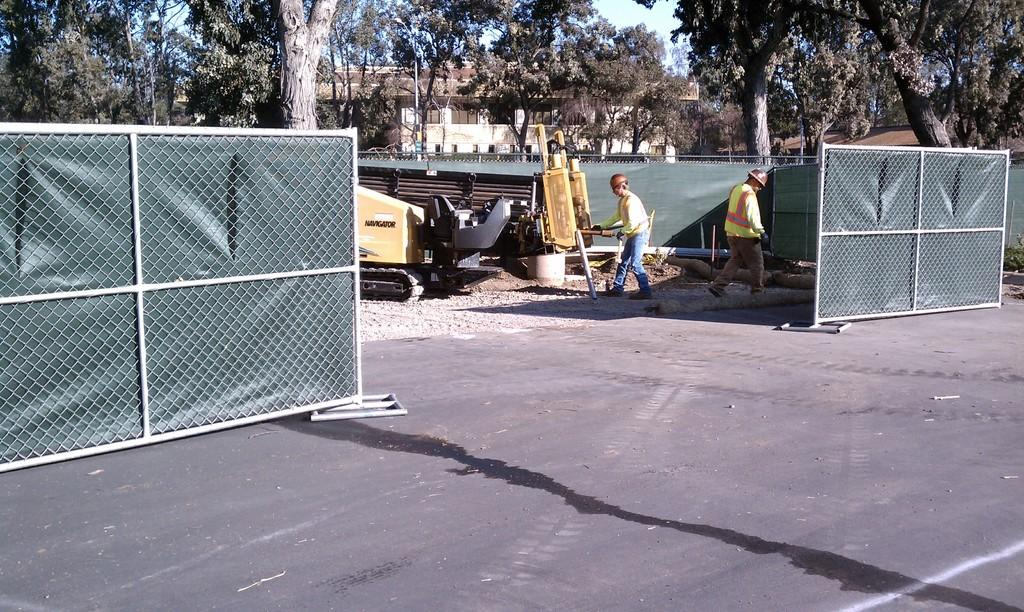What type of structure can be seen in the image? There is fencing in the image. How many people are in the image? There are two persons in the image. What else is present in the image besides the people and fencing? A vehicle, multiple trees, a building, and the sky are visible in the image. What are the two persons wearing on their heads? The two persons are wearing helmets. What type of clothing are the two persons wearing? The two persons are wearing jackets. Can you see a crown on the head of one of the persons in the image? No, there is no crown present in the image. What book is the person reading while sitting on the tree? There is no person reading a book in the image; the two persons are wearing helmets and jackets. 